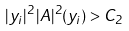<formula> <loc_0><loc_0><loc_500><loc_500>| y _ { i } | ^ { 2 } \, | A | ^ { 2 } ( y _ { i } ) > C _ { 2 }</formula> 